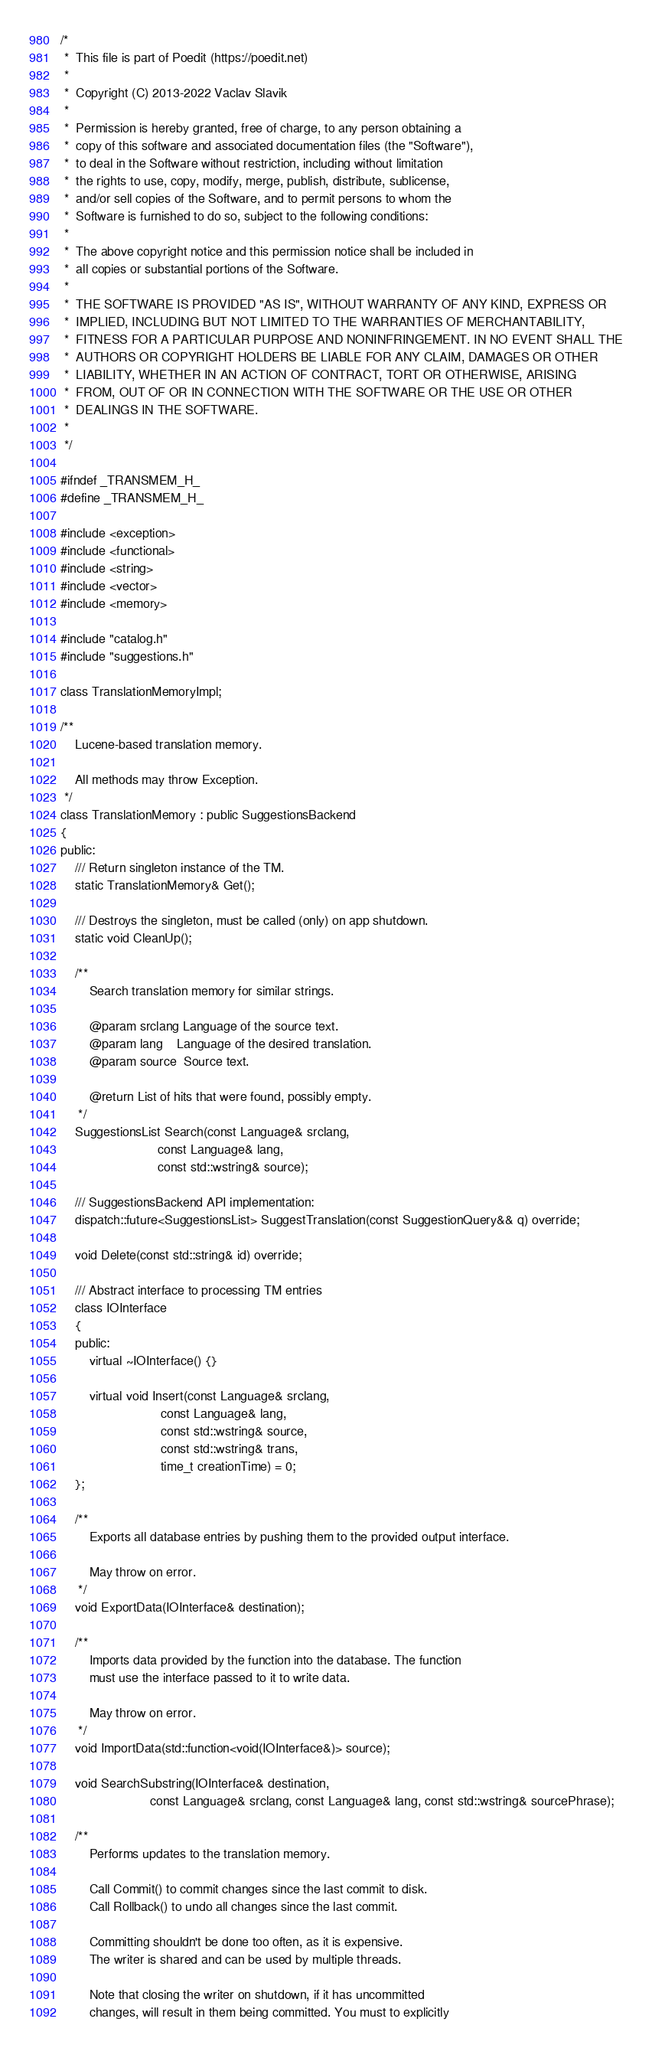Convert code to text. <code><loc_0><loc_0><loc_500><loc_500><_C_>/*
 *  This file is part of Poedit (https://poedit.net)
 *
 *  Copyright (C) 2013-2022 Vaclav Slavik
 *
 *  Permission is hereby granted, free of charge, to any person obtaining a
 *  copy of this software and associated documentation files (the "Software"),
 *  to deal in the Software without restriction, including without limitation
 *  the rights to use, copy, modify, merge, publish, distribute, sublicense,
 *  and/or sell copies of the Software, and to permit persons to whom the
 *  Software is furnished to do so, subject to the following conditions:
 *
 *  The above copyright notice and this permission notice shall be included in
 *  all copies or substantial portions of the Software.
 *
 *  THE SOFTWARE IS PROVIDED "AS IS", WITHOUT WARRANTY OF ANY KIND, EXPRESS OR
 *  IMPLIED, INCLUDING BUT NOT LIMITED TO THE WARRANTIES OF MERCHANTABILITY,
 *  FITNESS FOR A PARTICULAR PURPOSE AND NONINFRINGEMENT. IN NO EVENT SHALL THE
 *  AUTHORS OR COPYRIGHT HOLDERS BE LIABLE FOR ANY CLAIM, DAMAGES OR OTHER
 *  LIABILITY, WHETHER IN AN ACTION OF CONTRACT, TORT OR OTHERWISE, ARISING
 *  FROM, OUT OF OR IN CONNECTION WITH THE SOFTWARE OR THE USE OR OTHER
 *  DEALINGS IN THE SOFTWARE.
 *
 */

#ifndef _TRANSMEM_H_
#define _TRANSMEM_H_

#include <exception>
#include <functional>
#include <string>
#include <vector>
#include <memory>

#include "catalog.h"
#include "suggestions.h"

class TranslationMemoryImpl;

/** 
    Lucene-based translation memory.
    
    All methods may throw Exception.
 */
class TranslationMemory : public SuggestionsBackend
{
public:
    /// Return singleton instance of the TM.
    static TranslationMemory& Get();

    /// Destroys the singleton, must be called (only) on app shutdown.
    static void CleanUp();

    /**
        Search translation memory for similar strings.
        
        @param srclang Language of the source text.
        @param lang    Language of the desired translation.
        @param source  Source text.

        @return List of hits that were found, possibly empty.
     */
    SuggestionsList Search(const Language& srclang,
                           const Language& lang,
                           const std::wstring& source);

    /// SuggestionsBackend API implementation:
    dispatch::future<SuggestionsList> SuggestTranslation(const SuggestionQuery&& q) override;

    void Delete(const std::string& id) override;

    /// Abstract interface to processing TM entries
    class IOInterface
    {
    public:
        virtual ~IOInterface() {}

        virtual void Insert(const Language& srclang,
                            const Language& lang,
                            const std::wstring& source,
                            const std::wstring& trans,
                            time_t creationTime) = 0;
    };

    /**
        Exports all database entries by pushing them to the provided output interface.

        May throw on error.
     */
    void ExportData(IOInterface& destination);

    /**
        Imports data provided by the function into the database. The function
        must use the interface passed to it to write data.

        May throw on error.
     */
    void ImportData(std::function<void(IOInterface&)> source);

    void SearchSubstring(IOInterface& destination,
                         const Language& srclang, const Language& lang, const std::wstring& sourcePhrase);

    /**
        Performs updates to the translation memory.
        
        Call Commit() to commit changes since the last commit to disk.
        Call Rollback() to undo all changes since the last commit.
        
        Committing shouldn't be done too often, as it is expensive.
        The writer is shared and can be used by multiple threads.
        
        Note that closing the writer on shutdown, if it has uncommitted
        changes, will result in them being committed. You must to explicitly</code> 